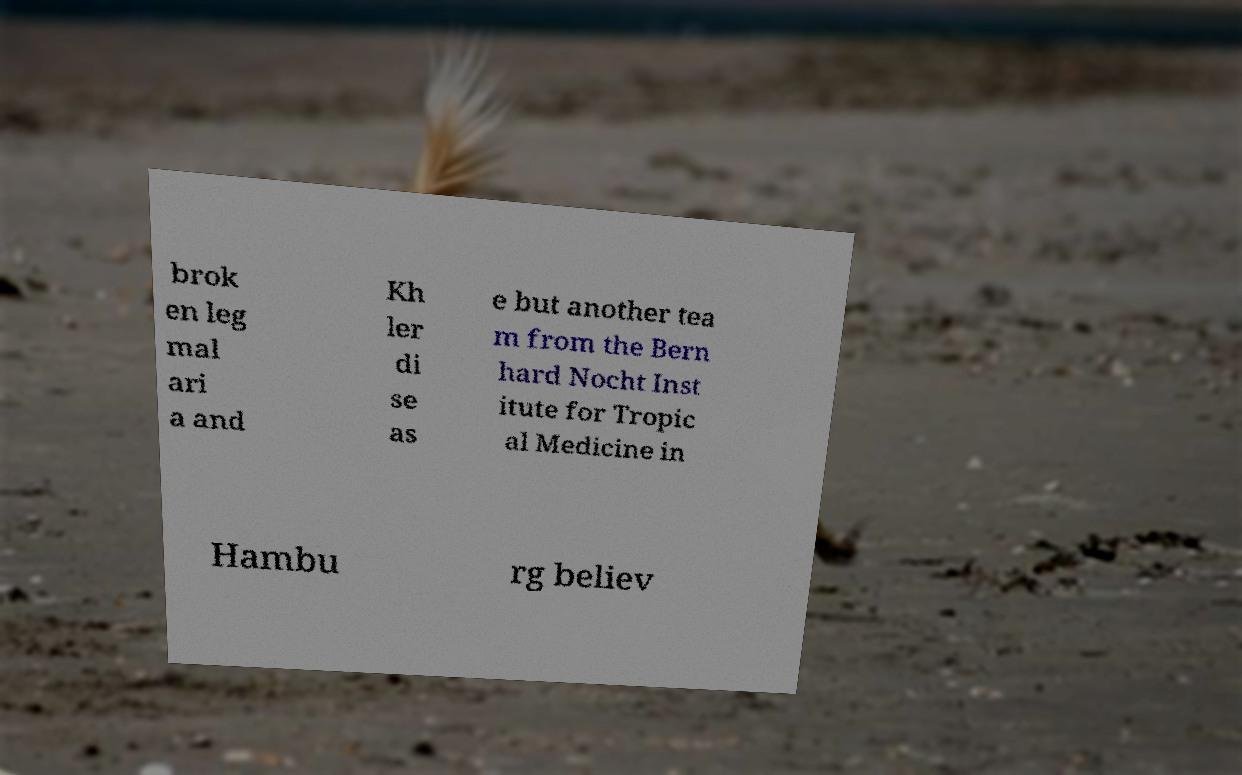Please read and relay the text visible in this image. What does it say? brok en leg mal ari a and Kh ler di se as e but another tea m from the Bern hard Nocht Inst itute for Tropic al Medicine in Hambu rg believ 